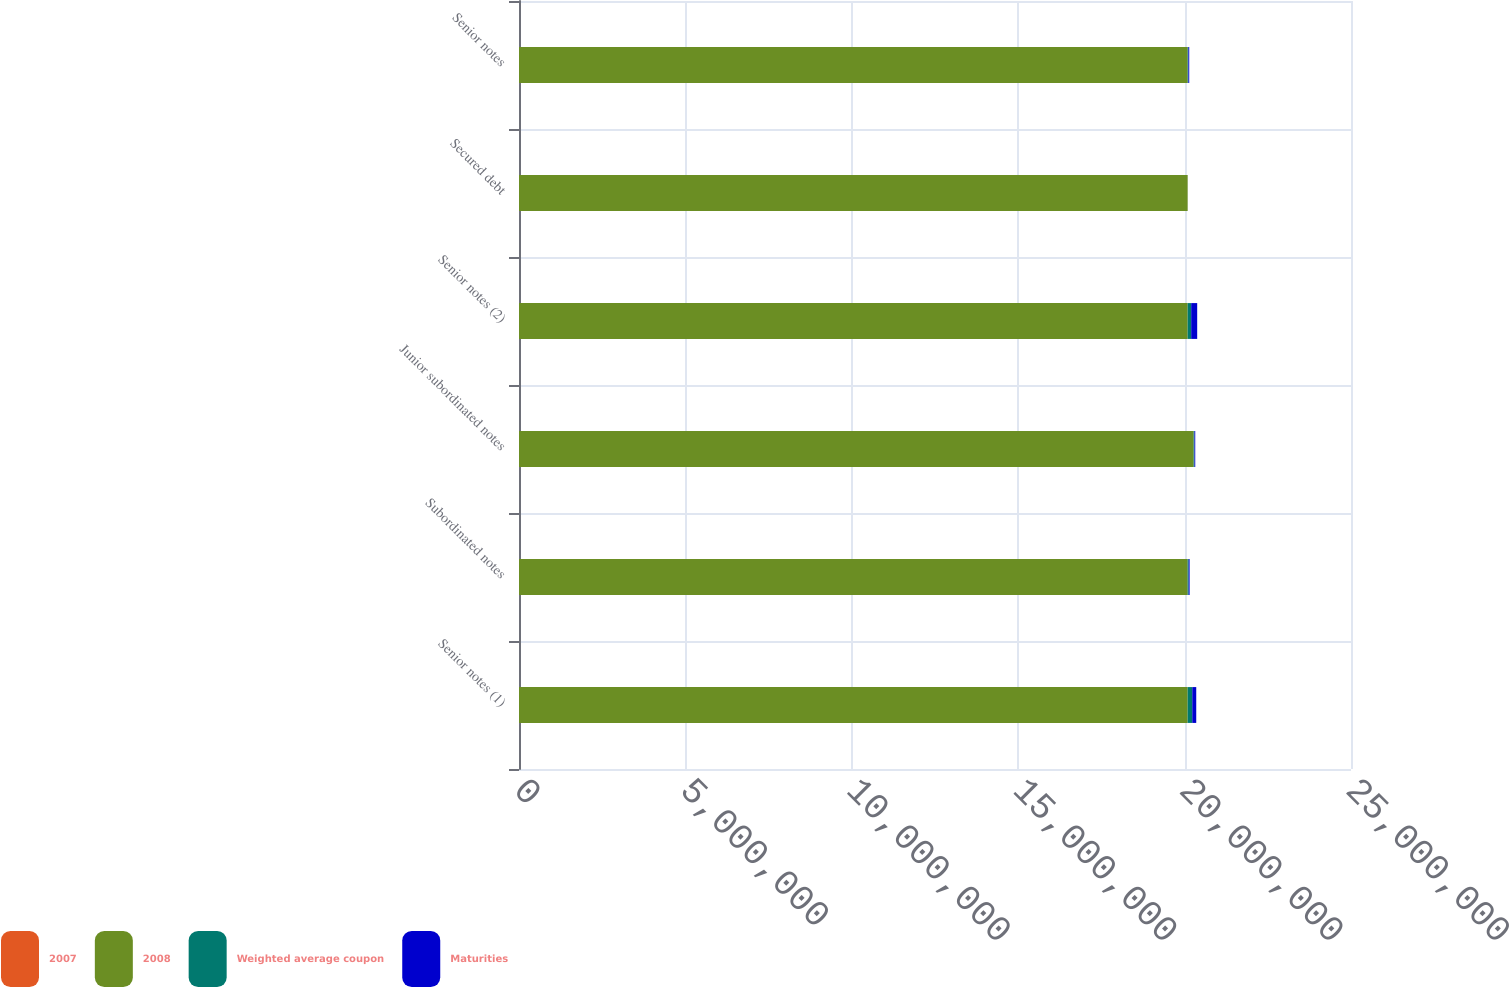Convert chart. <chart><loc_0><loc_0><loc_500><loc_500><stacked_bar_chart><ecel><fcel>Senior notes (1)<fcel>Subordinated notes<fcel>Junior subordinated notes<fcel>Senior notes (2)<fcel>Secured debt<fcel>Senior notes<nl><fcel>2007<fcel>4.33<fcel>5.37<fcel>6.94<fcel>2.69<fcel>2.92<fcel>3.72<nl><fcel>2008<fcel>2.00921e+07<fcel>2.0092e+07<fcel>2.02721e+07<fcel>2.0092e+07<fcel>2.0092e+07<fcel>2.00921e+07<nl><fcel>Weighted average coupon<fcel>138005<fcel>30216<fcel>24060<fcel>105629<fcel>290<fcel>20619<nl><fcel>Maturities<fcel>119680<fcel>28185<fcel>23756<fcel>180689<fcel>433<fcel>26545<nl></chart> 